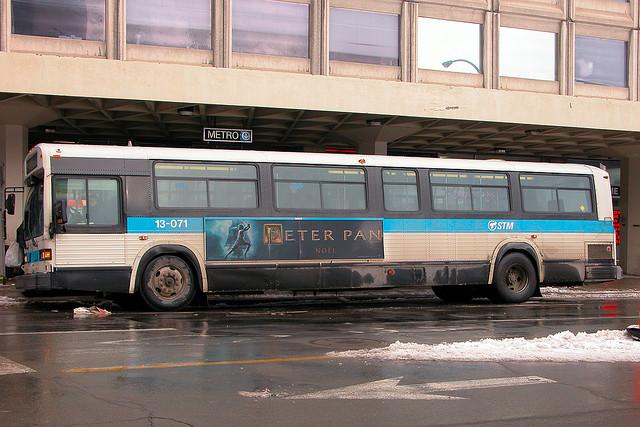What # is the bus?
Quick response, please. 13-071. What form of entertainment is advertised?
Answer briefly. Movie. How many windows are in the bus?
Write a very short answer. 6. 